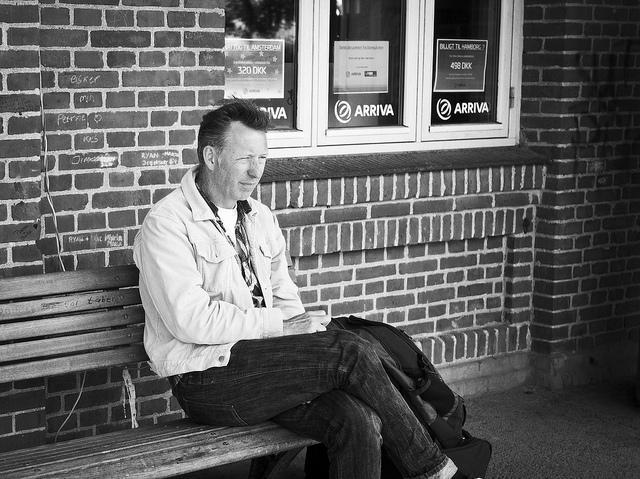How many carrots are on the plate?
Give a very brief answer. 0. 